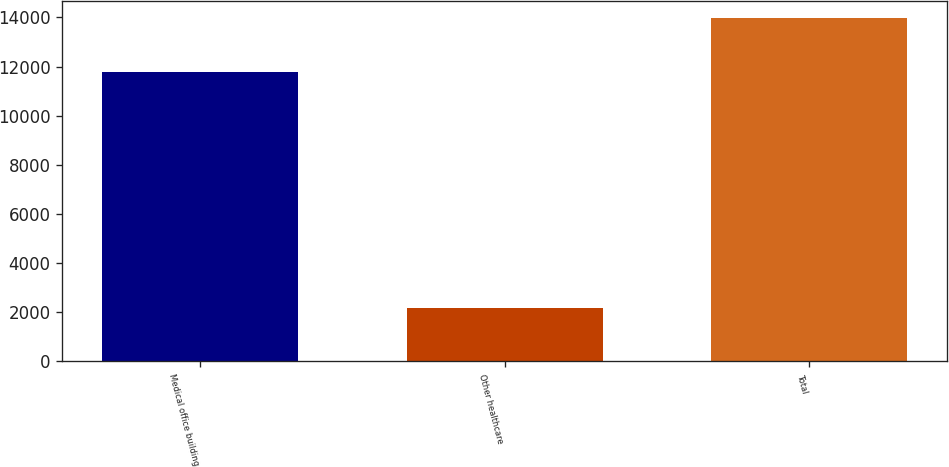<chart> <loc_0><loc_0><loc_500><loc_500><bar_chart><fcel>Medical office building<fcel>Other healthcare<fcel>Total<nl><fcel>11796<fcel>2187<fcel>13983<nl></chart> 